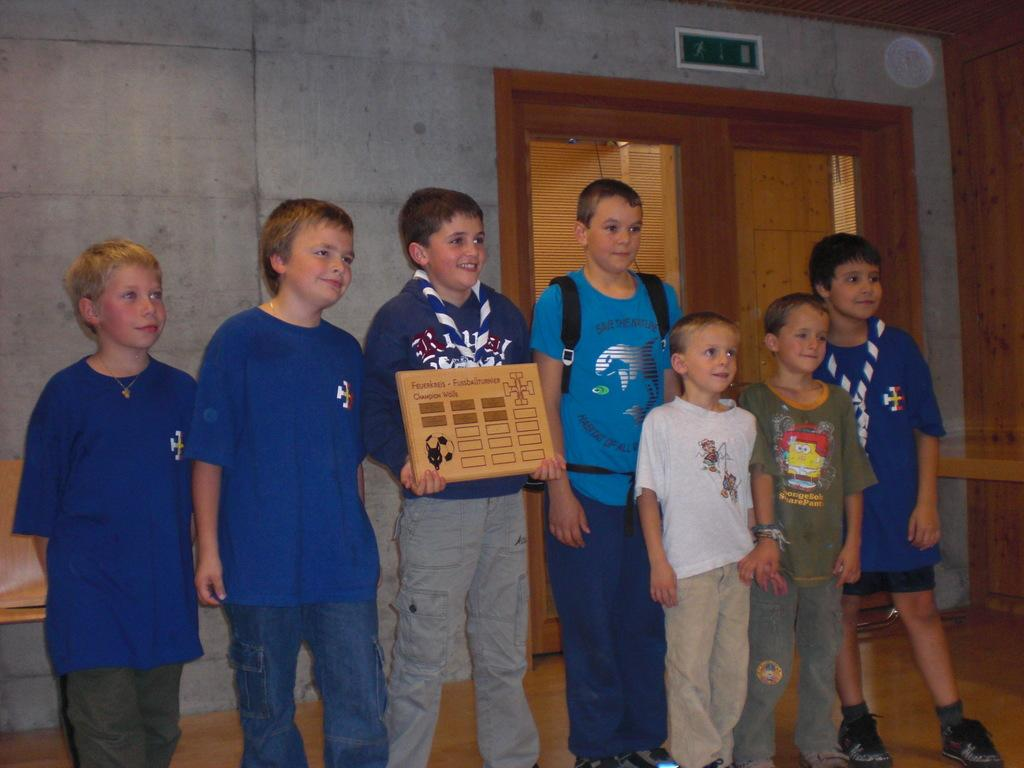What is happening in the image? There are people standing in the image. Can you describe what one of the people is doing? There is a person holding an object in the image. What can be seen in the background of the image? There is a wall and a wooden door visible in the background of the image. What type of land can be seen in the image? There is no land visible in the image; it features people standing in front of a wall and a wooden door. What answer is being provided by the person holding the object in the image? The image does not show any answers being provided, as it only depicts people standing and holding an object. 